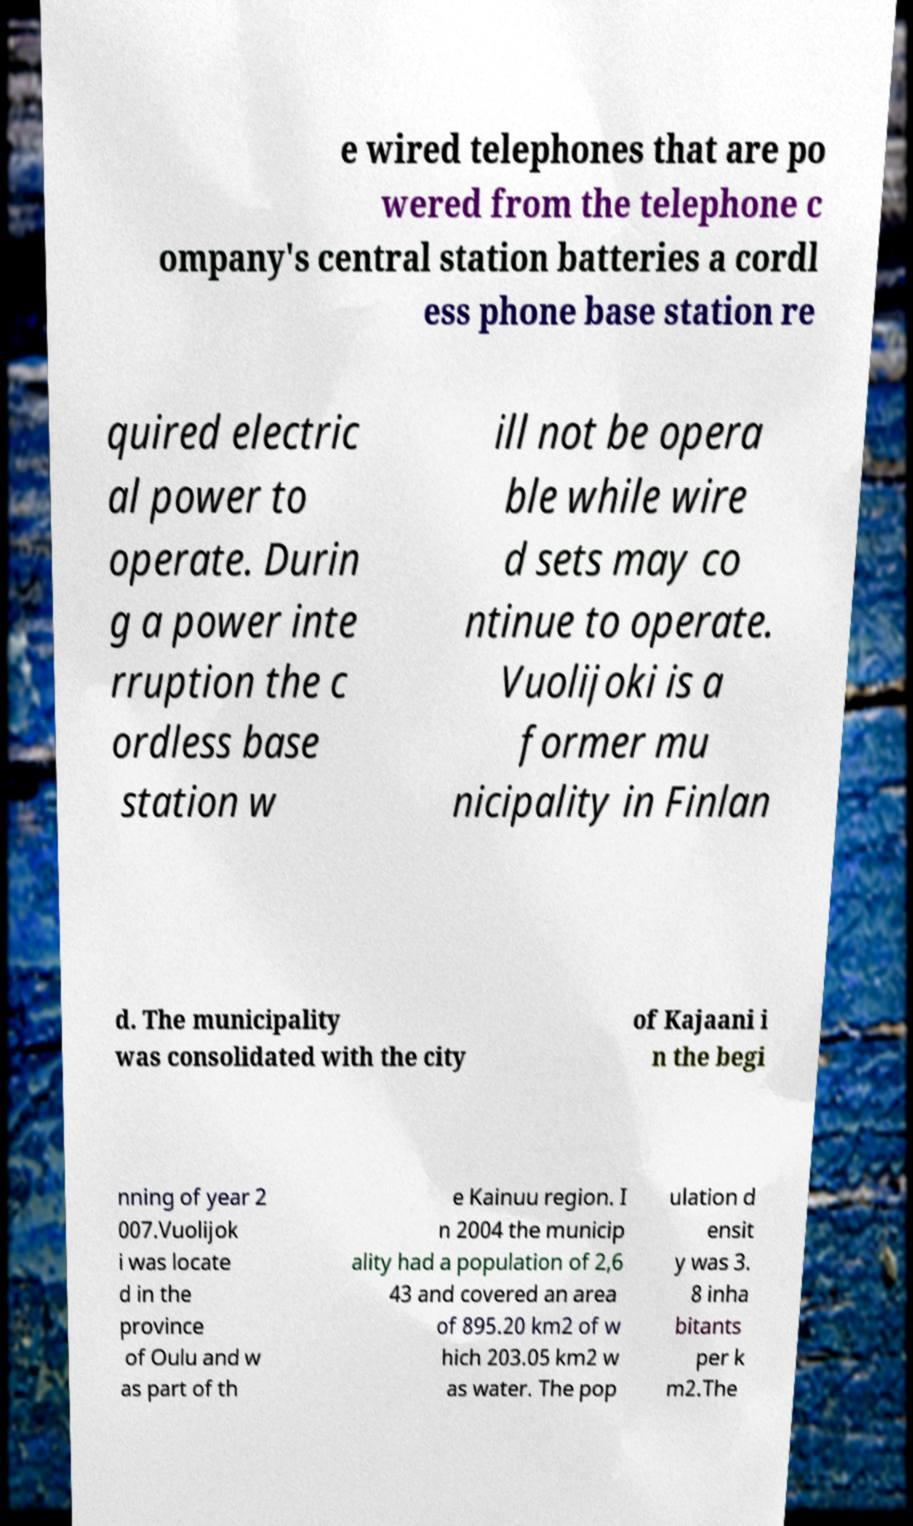Please identify and transcribe the text found in this image. e wired telephones that are po wered from the telephone c ompany's central station batteries a cordl ess phone base station re quired electric al power to operate. Durin g a power inte rruption the c ordless base station w ill not be opera ble while wire d sets may co ntinue to operate. Vuolijoki is a former mu nicipality in Finlan d. The municipality was consolidated with the city of Kajaani i n the begi nning of year 2 007.Vuolijok i was locate d in the province of Oulu and w as part of th e Kainuu region. I n 2004 the municip ality had a population of 2,6 43 and covered an area of 895.20 km2 of w hich 203.05 km2 w as water. The pop ulation d ensit y was 3. 8 inha bitants per k m2.The 